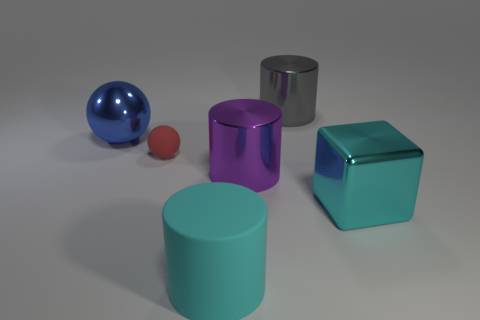How many cyan rubber things are to the right of the rubber cylinder? 0 